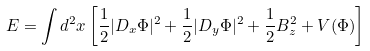Convert formula to latex. <formula><loc_0><loc_0><loc_500><loc_500>E = \int d ^ { 2 } x \left [ { \frac { 1 } { 2 } } | D _ { x } \Phi | ^ { 2 } + { \frac { 1 } { 2 } } | D _ { y } \Phi | ^ { 2 } + { \frac { 1 } { 2 } } B _ { z } ^ { 2 } + V ( \Phi ) \right ]</formula> 